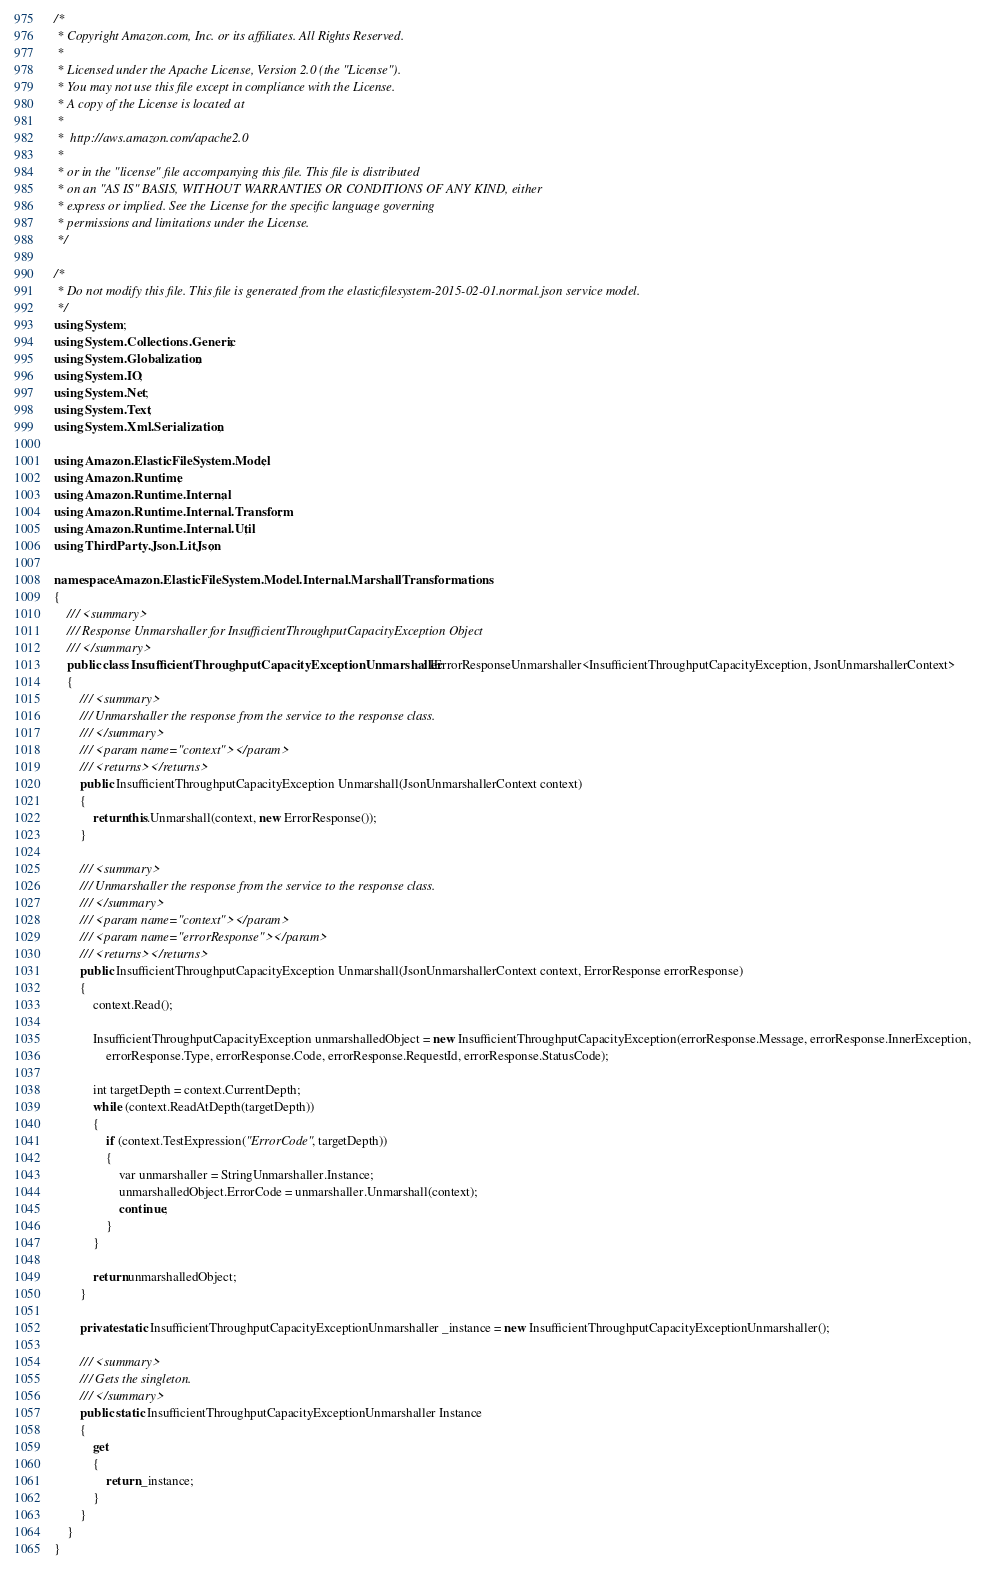Convert code to text. <code><loc_0><loc_0><loc_500><loc_500><_C#_>/*
 * Copyright Amazon.com, Inc. or its affiliates. All Rights Reserved.
 * 
 * Licensed under the Apache License, Version 2.0 (the "License").
 * You may not use this file except in compliance with the License.
 * A copy of the License is located at
 * 
 *  http://aws.amazon.com/apache2.0
 * 
 * or in the "license" file accompanying this file. This file is distributed
 * on an "AS IS" BASIS, WITHOUT WARRANTIES OR CONDITIONS OF ANY KIND, either
 * express or implied. See the License for the specific language governing
 * permissions and limitations under the License.
 */

/*
 * Do not modify this file. This file is generated from the elasticfilesystem-2015-02-01.normal.json service model.
 */
using System;
using System.Collections.Generic;
using System.Globalization;
using System.IO;
using System.Net;
using System.Text;
using System.Xml.Serialization;

using Amazon.ElasticFileSystem.Model;
using Amazon.Runtime;
using Amazon.Runtime.Internal;
using Amazon.Runtime.Internal.Transform;
using Amazon.Runtime.Internal.Util;
using ThirdParty.Json.LitJson;

namespace Amazon.ElasticFileSystem.Model.Internal.MarshallTransformations
{
    /// <summary>
    /// Response Unmarshaller for InsufficientThroughputCapacityException Object
    /// </summary>  
    public class InsufficientThroughputCapacityExceptionUnmarshaller : IErrorResponseUnmarshaller<InsufficientThroughputCapacityException, JsonUnmarshallerContext>
    {
        /// <summary>
        /// Unmarshaller the response from the service to the response class.
        /// </summary>  
        /// <param name="context"></param>
        /// <returns></returns>
        public InsufficientThroughputCapacityException Unmarshall(JsonUnmarshallerContext context)
        {
            return this.Unmarshall(context, new ErrorResponse());
        }

        /// <summary>
        /// Unmarshaller the response from the service to the response class.
        /// </summary>  
        /// <param name="context"></param>
        /// <param name="errorResponse"></param>
        /// <returns></returns>
        public InsufficientThroughputCapacityException Unmarshall(JsonUnmarshallerContext context, ErrorResponse errorResponse)
        {
            context.Read();

            InsufficientThroughputCapacityException unmarshalledObject = new InsufficientThroughputCapacityException(errorResponse.Message, errorResponse.InnerException,
                errorResponse.Type, errorResponse.Code, errorResponse.RequestId, errorResponse.StatusCode);
        
            int targetDepth = context.CurrentDepth;
            while (context.ReadAtDepth(targetDepth))
            {
                if (context.TestExpression("ErrorCode", targetDepth))
                {
                    var unmarshaller = StringUnmarshaller.Instance;
                    unmarshalledObject.ErrorCode = unmarshaller.Unmarshall(context);
                    continue;
                }
            }
          
            return unmarshalledObject;
        }

        private static InsufficientThroughputCapacityExceptionUnmarshaller _instance = new InsufficientThroughputCapacityExceptionUnmarshaller();        

        /// <summary>
        /// Gets the singleton.
        /// </summary>  
        public static InsufficientThroughputCapacityExceptionUnmarshaller Instance
        {
            get
            {
                return _instance;
            }
        }
    }
}</code> 